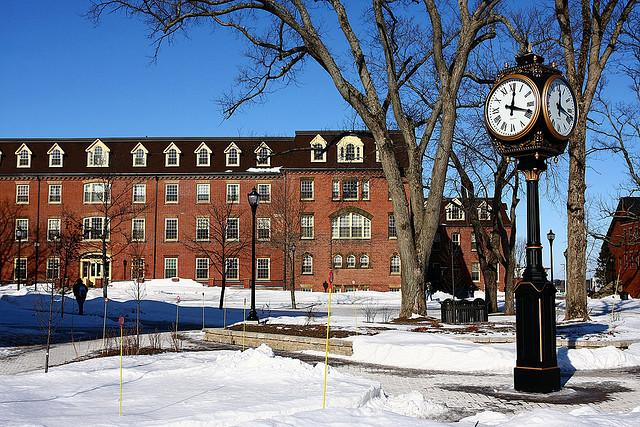What is the coldest place in the area?

Choices:
A) by clock
B) by building
C) by tree
D) shaded area shaded area 